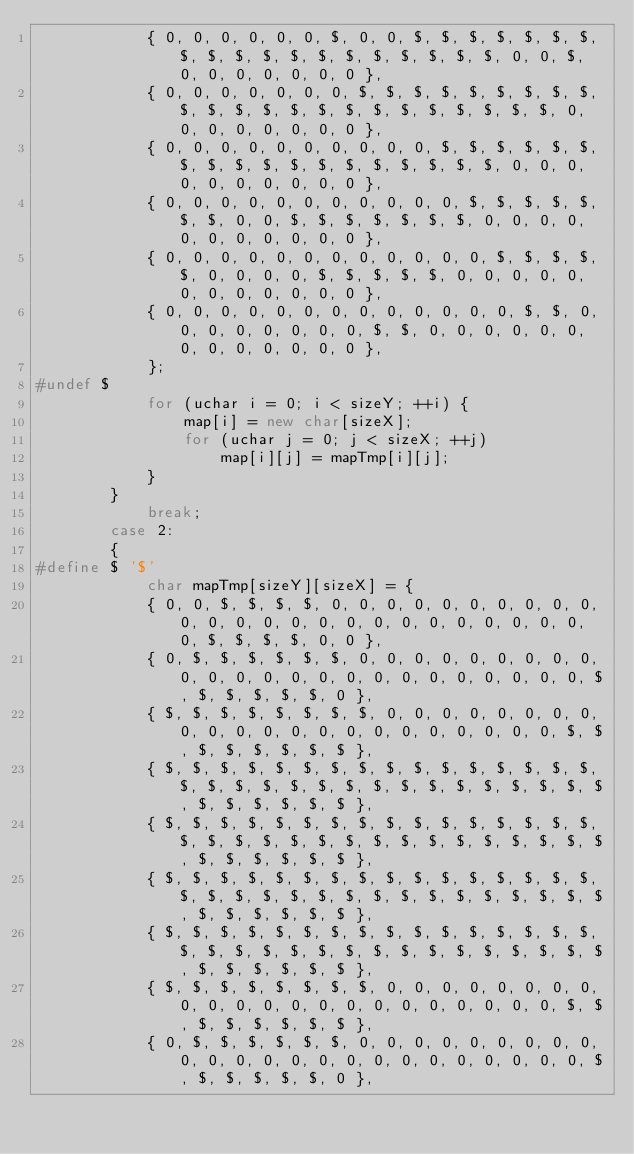<code> <loc_0><loc_0><loc_500><loc_500><_C++_>			{ 0, 0, 0, 0, 0, 0, $, 0, 0, $, $, $, $, $, $, $, $, $, $, $, $, $, $, $, $, $, $, $, 0, 0, $, 0, 0, 0, 0, 0, 0, 0 },
			{ 0, 0, 0, 0, 0, 0, 0, $, $, $, $, $, $, $, $, $, $, $, $, $, $, $, $, $, $, $, $, $, $, $, 0, 0, 0, 0, 0, 0, 0, 0 },
			{ 0, 0, 0, 0, 0, 0, 0, 0, 0, 0, $, $, $, $, $, $, $, $, $, $, $, $, $, $, $, $, $, $, 0, 0, 0, 0, 0, 0, 0, 0, 0, 0 },
			{ 0, 0, 0, 0, 0, 0, 0, 0, 0, 0, 0, $, $, $, $, $, $, $, 0, 0, $, $, $, $, $, $, $, 0, 0, 0, 0, 0, 0, 0, 0, 0, 0, 0 },
			{ 0, 0, 0, 0, 0, 0, 0, 0, 0, 0, 0, 0, $, $, $, $, $, 0, 0, 0, 0, $, $, $, $, $, 0, 0, 0, 0, 0, 0, 0, 0, 0, 0, 0, 0 },
			{ 0, 0, 0, 0, 0, 0, 0, 0, 0, 0, 0, 0, 0, $, $, 0, 0, 0, 0, 0, 0, 0, 0, $, $, 0, 0, 0, 0, 0, 0, 0, 0, 0, 0, 0, 0, 0 },
			};
#undef $
			for (uchar i = 0; i < sizeY; ++i) {
				map[i] = new char[sizeX];
				for (uchar j = 0; j < sizeX; ++j)
					map[i][j] = mapTmp[i][j];
			}
		}
			break;
		case 2:
		{
#define $ '$'
			char mapTmp[sizeY][sizeX] = {
			{ 0, 0, $, $, $, $, 0, 0, 0, 0, 0, 0, 0, 0, 0, 0, 0, 0, 0, 0, 0, 0, 0, 0, 0, 0, 0, 0, 0, 0, 0, 0, $, $, $, $, 0, 0 },
			{ 0, $, $, $, $, $, $, 0, 0, 0, 0, 0, 0, 0, 0, 0, 0, 0, 0, 0, 0, 0, 0, 0, 0, 0, 0, 0, 0, 0, 0, $, $, $, $, $, $, 0 },
			{ $, $, $, $, $, $, $, $, 0, 0, 0, 0, 0, 0, 0, 0, 0, 0, 0, 0, 0, 0, 0, 0, 0, 0, 0, 0, 0, 0, $, $, $, $, $, $, $, $ },
			{ $, $, $, $, $, $, $, $, $, $, $, $, $, $, $, $, $, $, $, $, $, $, $, $, $, $, $, $, $, $, $, $, $, $, $, $, $, $ },
			{ $, $, $, $, $, $, $, $, $, $, $, $, $, $, $, $, $, $, $, $, $, $, $, $, $, $, $, $, $, $, $, $, $, $, $, $, $, $ },
			{ $, $, $, $, $, $, $, $, $, $, $, $, $, $, $, $, $, $, $, $, $, $, $, $, $, $, $, $, $, $, $, $, $, $, $, $, $, $ },
			{ $, $, $, $, $, $, $, $, $, $, $, $, $, $, $, $, $, $, $, $, $, $, $, $, $, $, $, $, $, $, $, $, $, $, $, $, $, $ },
			{ $, $, $, $, $, $, $, $, 0, 0, 0, 0, 0, 0, 0, 0, 0, 0, 0, 0, 0, 0, 0, 0, 0, 0, 0, 0, 0, 0, $, $, $, $, $, $, $, $ },
			{ 0, $, $, $, $, $, $, 0, 0, 0, 0, 0, 0, 0, 0, 0, 0, 0, 0, 0, 0, 0, 0, 0, 0, 0, 0, 0, 0, 0, 0, $, $, $, $, $, $, 0 },</code> 